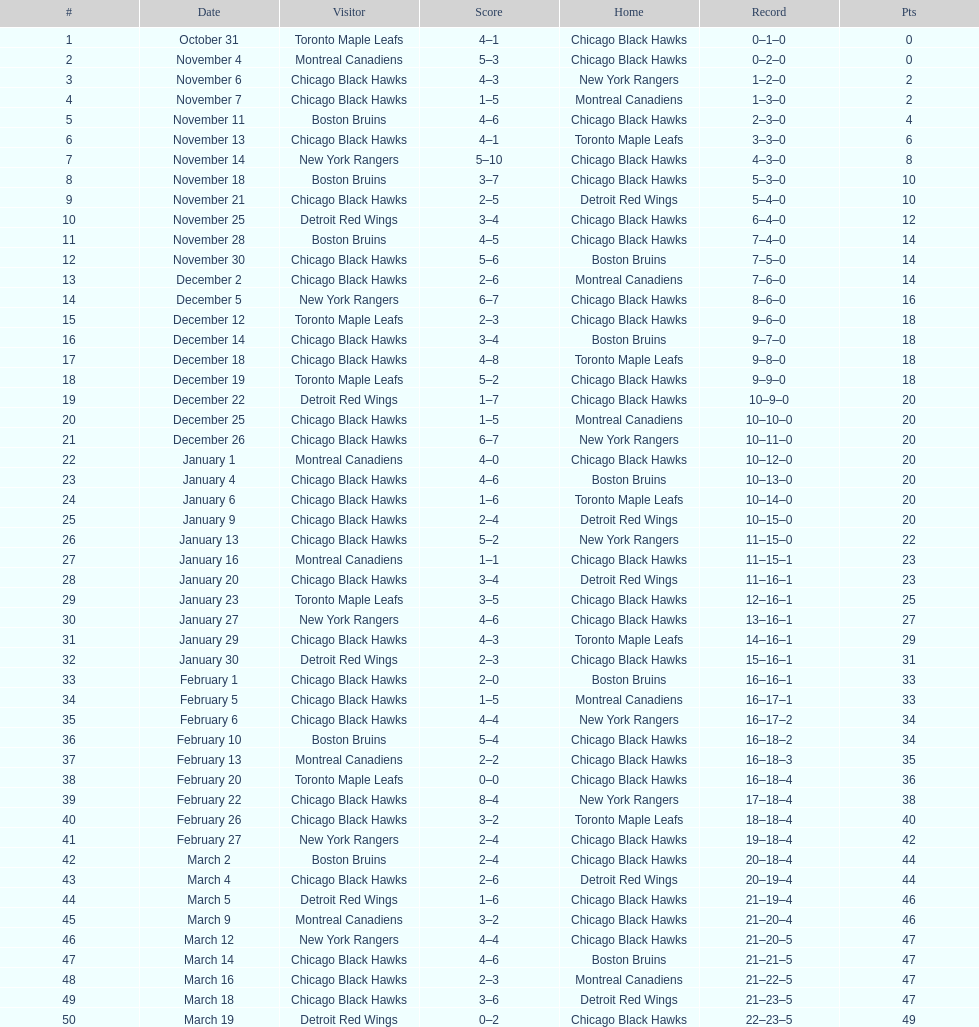Were the chicago blackhawks or the boston bruins the home team on december 14? Boston Bruins. Write the full table. {'header': ['#', 'Date', 'Visitor', 'Score', 'Home', 'Record', 'Pts'], 'rows': [['1', 'October 31', 'Toronto Maple Leafs', '4–1', 'Chicago Black Hawks', '0–1–0', '0'], ['2', 'November 4', 'Montreal Canadiens', '5–3', 'Chicago Black Hawks', '0–2–0', '0'], ['3', 'November 6', 'Chicago Black Hawks', '4–3', 'New York Rangers', '1–2–0', '2'], ['4', 'November 7', 'Chicago Black Hawks', '1–5', 'Montreal Canadiens', '1–3–0', '2'], ['5', 'November 11', 'Boston Bruins', '4–6', 'Chicago Black Hawks', '2–3–0', '4'], ['6', 'November 13', 'Chicago Black Hawks', '4–1', 'Toronto Maple Leafs', '3–3–0', '6'], ['7', 'November 14', 'New York Rangers', '5–10', 'Chicago Black Hawks', '4–3–0', '8'], ['8', 'November 18', 'Boston Bruins', '3–7', 'Chicago Black Hawks', '5–3–0', '10'], ['9', 'November 21', 'Chicago Black Hawks', '2–5', 'Detroit Red Wings', '5–4–0', '10'], ['10', 'November 25', 'Detroit Red Wings', '3–4', 'Chicago Black Hawks', '6–4–0', '12'], ['11', 'November 28', 'Boston Bruins', '4–5', 'Chicago Black Hawks', '7–4–0', '14'], ['12', 'November 30', 'Chicago Black Hawks', '5–6', 'Boston Bruins', '7–5–0', '14'], ['13', 'December 2', 'Chicago Black Hawks', '2–6', 'Montreal Canadiens', '7–6–0', '14'], ['14', 'December 5', 'New York Rangers', '6–7', 'Chicago Black Hawks', '8–6–0', '16'], ['15', 'December 12', 'Toronto Maple Leafs', '2–3', 'Chicago Black Hawks', '9–6–0', '18'], ['16', 'December 14', 'Chicago Black Hawks', '3–4', 'Boston Bruins', '9–7–0', '18'], ['17', 'December 18', 'Chicago Black Hawks', '4–8', 'Toronto Maple Leafs', '9–8–0', '18'], ['18', 'December 19', 'Toronto Maple Leafs', '5–2', 'Chicago Black Hawks', '9–9–0', '18'], ['19', 'December 22', 'Detroit Red Wings', '1–7', 'Chicago Black Hawks', '10–9–0', '20'], ['20', 'December 25', 'Chicago Black Hawks', '1–5', 'Montreal Canadiens', '10–10–0', '20'], ['21', 'December 26', 'Chicago Black Hawks', '6–7', 'New York Rangers', '10–11–0', '20'], ['22', 'January 1', 'Montreal Canadiens', '4–0', 'Chicago Black Hawks', '10–12–0', '20'], ['23', 'January 4', 'Chicago Black Hawks', '4–6', 'Boston Bruins', '10–13–0', '20'], ['24', 'January 6', 'Chicago Black Hawks', '1–6', 'Toronto Maple Leafs', '10–14–0', '20'], ['25', 'January 9', 'Chicago Black Hawks', '2–4', 'Detroit Red Wings', '10–15–0', '20'], ['26', 'January 13', 'Chicago Black Hawks', '5–2', 'New York Rangers', '11–15–0', '22'], ['27', 'January 16', 'Montreal Canadiens', '1–1', 'Chicago Black Hawks', '11–15–1', '23'], ['28', 'January 20', 'Chicago Black Hawks', '3–4', 'Detroit Red Wings', '11–16–1', '23'], ['29', 'January 23', 'Toronto Maple Leafs', '3–5', 'Chicago Black Hawks', '12–16–1', '25'], ['30', 'January 27', 'New York Rangers', '4–6', 'Chicago Black Hawks', '13–16–1', '27'], ['31', 'January 29', 'Chicago Black Hawks', '4–3', 'Toronto Maple Leafs', '14–16–1', '29'], ['32', 'January 30', 'Detroit Red Wings', '2–3', 'Chicago Black Hawks', '15–16–1', '31'], ['33', 'February 1', 'Chicago Black Hawks', '2–0', 'Boston Bruins', '16–16–1', '33'], ['34', 'February 5', 'Chicago Black Hawks', '1–5', 'Montreal Canadiens', '16–17–1', '33'], ['35', 'February 6', 'Chicago Black Hawks', '4–4', 'New York Rangers', '16–17–2', '34'], ['36', 'February 10', 'Boston Bruins', '5–4', 'Chicago Black Hawks', '16–18–2', '34'], ['37', 'February 13', 'Montreal Canadiens', '2–2', 'Chicago Black Hawks', '16–18–3', '35'], ['38', 'February 20', 'Toronto Maple Leafs', '0–0', 'Chicago Black Hawks', '16–18–4', '36'], ['39', 'February 22', 'Chicago Black Hawks', '8–4', 'New York Rangers', '17–18–4', '38'], ['40', 'February 26', 'Chicago Black Hawks', '3–2', 'Toronto Maple Leafs', '18–18–4', '40'], ['41', 'February 27', 'New York Rangers', '2–4', 'Chicago Black Hawks', '19–18–4', '42'], ['42', 'March 2', 'Boston Bruins', '2–4', 'Chicago Black Hawks', '20–18–4', '44'], ['43', 'March 4', 'Chicago Black Hawks', '2–6', 'Detroit Red Wings', '20–19–4', '44'], ['44', 'March 5', 'Detroit Red Wings', '1–6', 'Chicago Black Hawks', '21–19–4', '46'], ['45', 'March 9', 'Montreal Canadiens', '3–2', 'Chicago Black Hawks', '21–20–4', '46'], ['46', 'March 12', 'New York Rangers', '4–4', 'Chicago Black Hawks', '21–20–5', '47'], ['47', 'March 14', 'Chicago Black Hawks', '4–6', 'Boston Bruins', '21–21–5', '47'], ['48', 'March 16', 'Chicago Black Hawks', '2–3', 'Montreal Canadiens', '21–22–5', '47'], ['49', 'March 18', 'Chicago Black Hawks', '3–6', 'Detroit Red Wings', '21–23–5', '47'], ['50', 'March 19', 'Detroit Red Wings', '0–2', 'Chicago Black Hawks', '22–23–5', '49']]} 